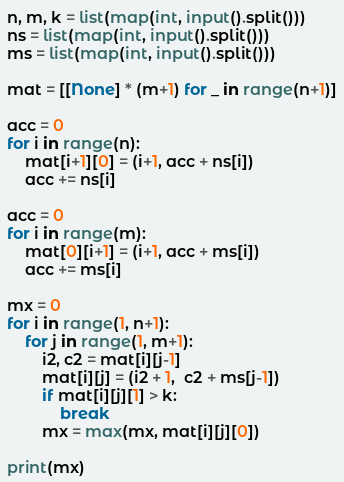Convert code to text. <code><loc_0><loc_0><loc_500><loc_500><_Python_>n, m, k = list(map(int, input().split()))
ns = list(map(int, input().split()))
ms = list(map(int, input().split()))

mat = [[None] * (m+1) for _ in range(n+1)]

acc = 0
for i in range(n):
    mat[i+1][0] = (i+1, acc + ns[i])
    acc += ns[i]

acc = 0
for i in range(m):
    mat[0][i+1] = (i+1, acc + ms[i])
    acc += ms[i]

mx = 0
for i in range(1, n+1):
    for j in range(1, m+1):
        i2, c2 = mat[i][j-1]
        mat[i][j] = (i2 + 1,  c2 + ms[j-1])
        if mat[i][j][1] > k:
            break
        mx = max(mx, mat[i][j][0])

print(mx)</code> 